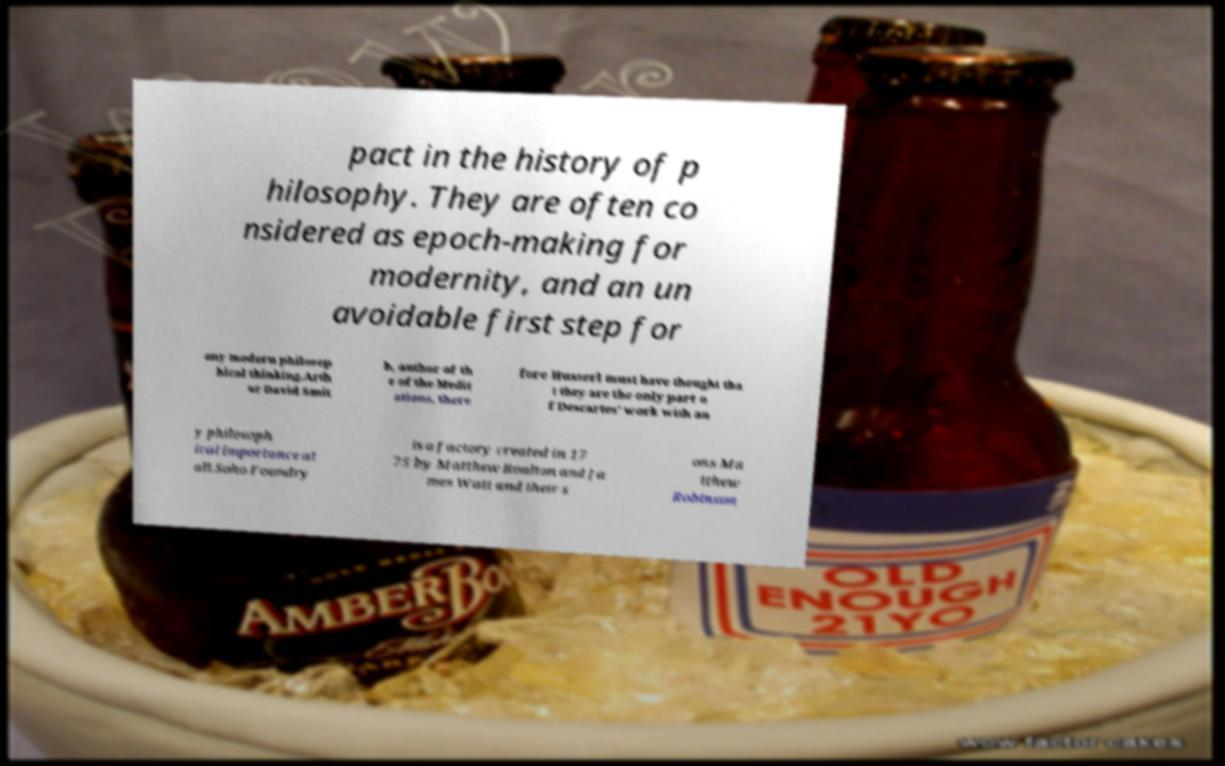Please read and relay the text visible in this image. What does it say? pact in the history of p hilosophy. They are often co nsidered as epoch-making for modernity, and an un avoidable first step for any modern philosop hical thinking.Arth ur David Smit h, author of th e of the Medit ations, there fore Husserl must have thought tha t they are the only part o f Descartes' work with an y philosoph ical importance at all.Soho Foundry is a factory created in 17 75 by Matthew Boulton and Ja mes Watt and their s ons Ma tthew Robinson 